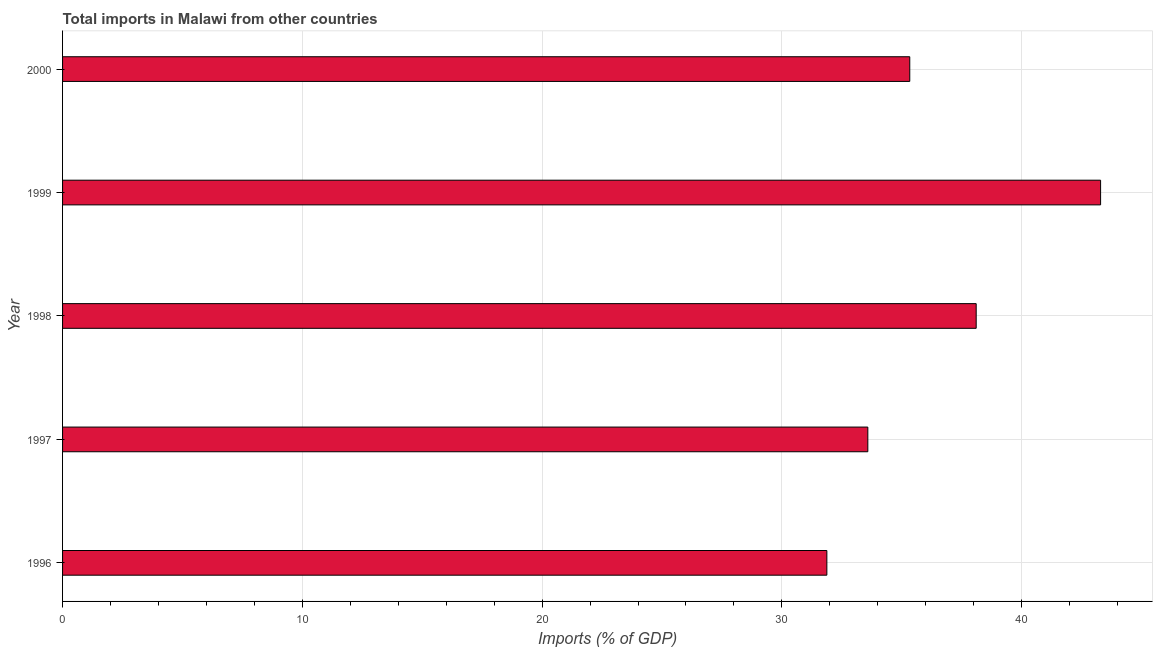Does the graph contain grids?
Your answer should be compact. Yes. What is the title of the graph?
Your answer should be very brief. Total imports in Malawi from other countries. What is the label or title of the X-axis?
Provide a succinct answer. Imports (% of GDP). What is the total imports in 1996?
Give a very brief answer. 31.88. Across all years, what is the maximum total imports?
Make the answer very short. 43.29. Across all years, what is the minimum total imports?
Your answer should be very brief. 31.88. What is the sum of the total imports?
Provide a short and direct response. 182.2. What is the difference between the total imports in 1999 and 2000?
Offer a terse response. 7.96. What is the average total imports per year?
Ensure brevity in your answer.  36.44. What is the median total imports?
Make the answer very short. 35.33. In how many years, is the total imports greater than 12 %?
Your response must be concise. 5. Do a majority of the years between 1998 and 1996 (inclusive) have total imports greater than 30 %?
Give a very brief answer. Yes. What is the ratio of the total imports in 1999 to that in 2000?
Your response must be concise. 1.23. Is the total imports in 1996 less than that in 1998?
Offer a very short reply. Yes. Is the difference between the total imports in 1996 and 1997 greater than the difference between any two years?
Offer a very short reply. No. What is the difference between the highest and the second highest total imports?
Your response must be concise. 5.19. What is the difference between the highest and the lowest total imports?
Your answer should be very brief. 11.42. How many bars are there?
Offer a terse response. 5. How many years are there in the graph?
Keep it short and to the point. 5. Are the values on the major ticks of X-axis written in scientific E-notation?
Offer a terse response. No. What is the Imports (% of GDP) of 1996?
Make the answer very short. 31.88. What is the Imports (% of GDP) in 1997?
Make the answer very short. 33.59. What is the Imports (% of GDP) in 1998?
Make the answer very short. 38.11. What is the Imports (% of GDP) in 1999?
Ensure brevity in your answer.  43.29. What is the Imports (% of GDP) in 2000?
Offer a terse response. 35.33. What is the difference between the Imports (% of GDP) in 1996 and 1997?
Ensure brevity in your answer.  -1.71. What is the difference between the Imports (% of GDP) in 1996 and 1998?
Make the answer very short. -6.23. What is the difference between the Imports (% of GDP) in 1996 and 1999?
Provide a succinct answer. -11.42. What is the difference between the Imports (% of GDP) in 1996 and 2000?
Your answer should be compact. -3.46. What is the difference between the Imports (% of GDP) in 1997 and 1998?
Keep it short and to the point. -4.52. What is the difference between the Imports (% of GDP) in 1997 and 1999?
Your response must be concise. -9.71. What is the difference between the Imports (% of GDP) in 1997 and 2000?
Give a very brief answer. -1.75. What is the difference between the Imports (% of GDP) in 1998 and 1999?
Keep it short and to the point. -5.19. What is the difference between the Imports (% of GDP) in 1998 and 2000?
Give a very brief answer. 2.77. What is the difference between the Imports (% of GDP) in 1999 and 2000?
Your answer should be compact. 7.96. What is the ratio of the Imports (% of GDP) in 1996 to that in 1997?
Provide a succinct answer. 0.95. What is the ratio of the Imports (% of GDP) in 1996 to that in 1998?
Ensure brevity in your answer.  0.84. What is the ratio of the Imports (% of GDP) in 1996 to that in 1999?
Keep it short and to the point. 0.74. What is the ratio of the Imports (% of GDP) in 1996 to that in 2000?
Offer a terse response. 0.9. What is the ratio of the Imports (% of GDP) in 1997 to that in 1998?
Offer a very short reply. 0.88. What is the ratio of the Imports (% of GDP) in 1997 to that in 1999?
Provide a succinct answer. 0.78. What is the ratio of the Imports (% of GDP) in 1997 to that in 2000?
Your answer should be compact. 0.95. What is the ratio of the Imports (% of GDP) in 1998 to that in 1999?
Offer a terse response. 0.88. What is the ratio of the Imports (% of GDP) in 1998 to that in 2000?
Your response must be concise. 1.08. What is the ratio of the Imports (% of GDP) in 1999 to that in 2000?
Provide a short and direct response. 1.23. 